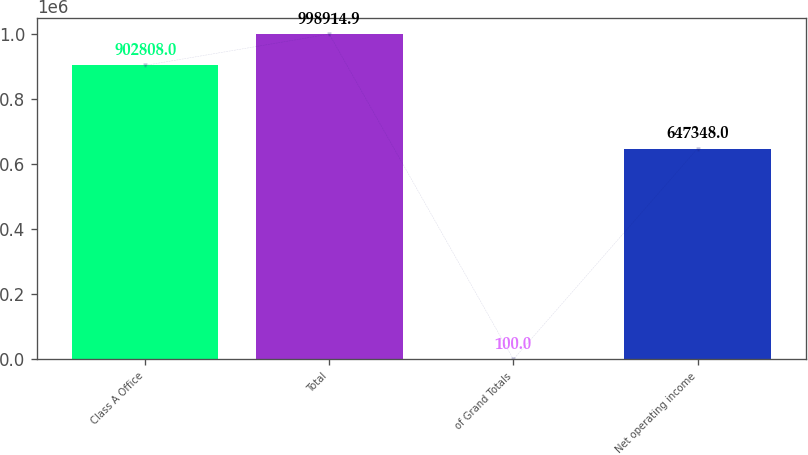Convert chart. <chart><loc_0><loc_0><loc_500><loc_500><bar_chart><fcel>Class A Office<fcel>Total<fcel>of Grand Totals<fcel>Net operating income<nl><fcel>902808<fcel>998915<fcel>100<fcel>647348<nl></chart> 